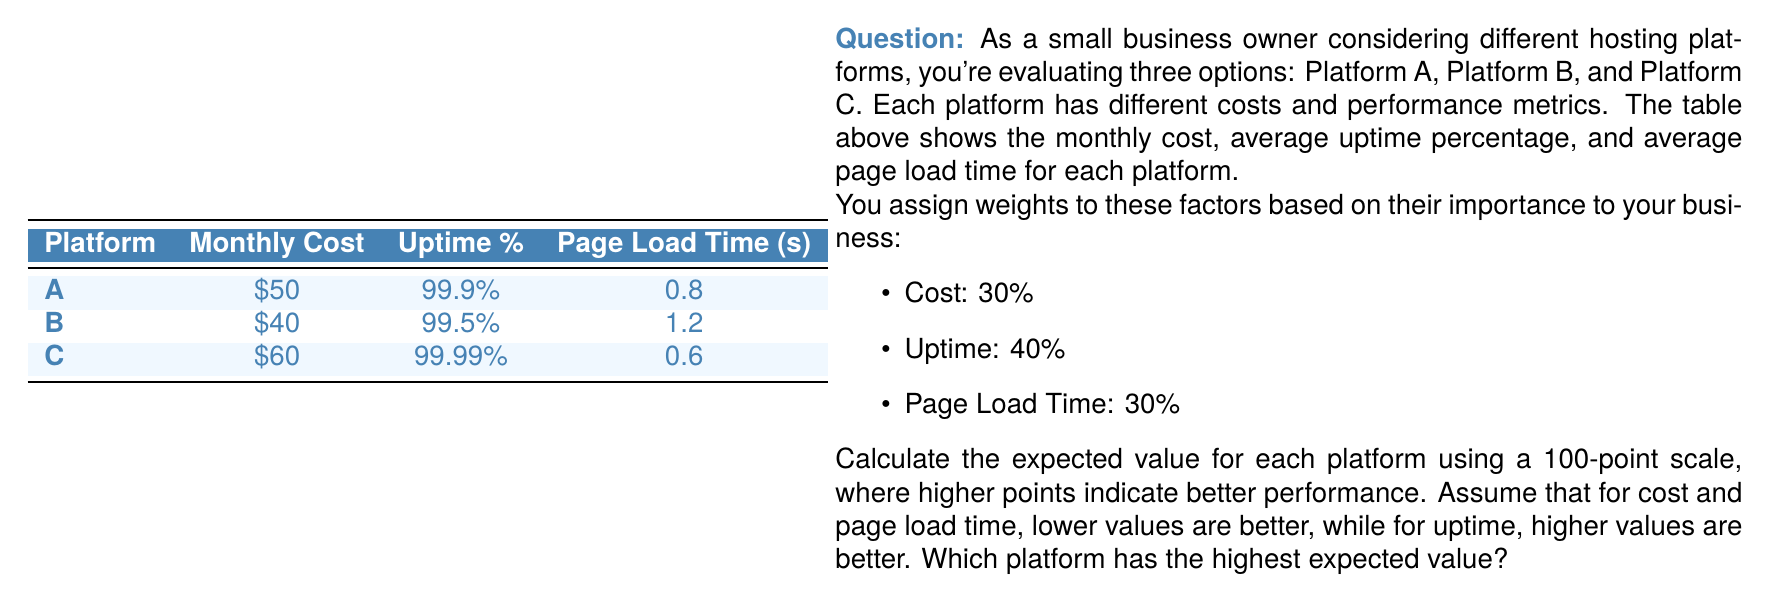Could you help me with this problem? To calculate the expected value for each platform, we'll use a 100-point scale for each factor and then apply the weights. Here's the step-by-step process:

1. Normalize the values for each factor on a 100-point scale:

   For cost and page load time (lower is better):
   $$ \text{Points} = 100 \times \frac{\text{Max value} - \text{Actual value}}{\text{Max value} - \text{Min value}} $$

   For uptime (higher is better):
   $$ \text{Points} = 100 \times \frac{\text{Actual value} - \text{Min value}}{\text{Max value} - \text{Min value}} $$

2. Calculate points for each factor:

   Cost:
   - A: $100 \times \frac{60 - 50}{60 - 40} = 50$ points
   - B: $100 \times \frac{60 - 40}{60 - 40} = 100$ points
   - C: $100 \times \frac{60 - 60}{60 - 40} = 0$ points

   Uptime:
   - A: $100 \times \frac{99.9 - 99.5}{99.99 - 99.5} = 81.63$ points
   - B: $100 \times \frac{99.5 - 99.5}{99.99 - 99.5} = 0$ points
   - C: $100 \times \frac{99.99 - 99.5}{99.99 - 99.5} = 100$ points

   Page Load Time:
   - A: $100 \times \frac{1.2 - 0.8}{1.2 - 0.6} = 66.67$ points
   - B: $100 \times \frac{1.2 - 1.2}{1.2 - 0.6} = 0$ points
   - C: $100 \times \frac{1.2 - 0.6}{1.2 - 0.6} = 100$ points

3. Apply weights and calculate the expected value:

   $$ \text{Expected Value} = 0.3 \times \text{Cost points} + 0.4 \times \text{Uptime points} + 0.3 \times \text{Page Load Time points} $$

   Platform A: $0.3 \times 50 + 0.4 \times 81.63 + 0.3 \times 66.67 = 67.32$
   Platform B: $0.3 \times 100 + 0.4 \times 0 + 0.3 \times 0 = 30$
   Platform C: $0.3 \times 0 + 0.4 \times 100 + 0.3 \times 100 = 70$

4. Compare the expected values:
   Platform A: 67.32
   Platform B: 30
   Platform C: 70

Platform C has the highest expected value of 70 points.
Answer: Platform C (70 points) 